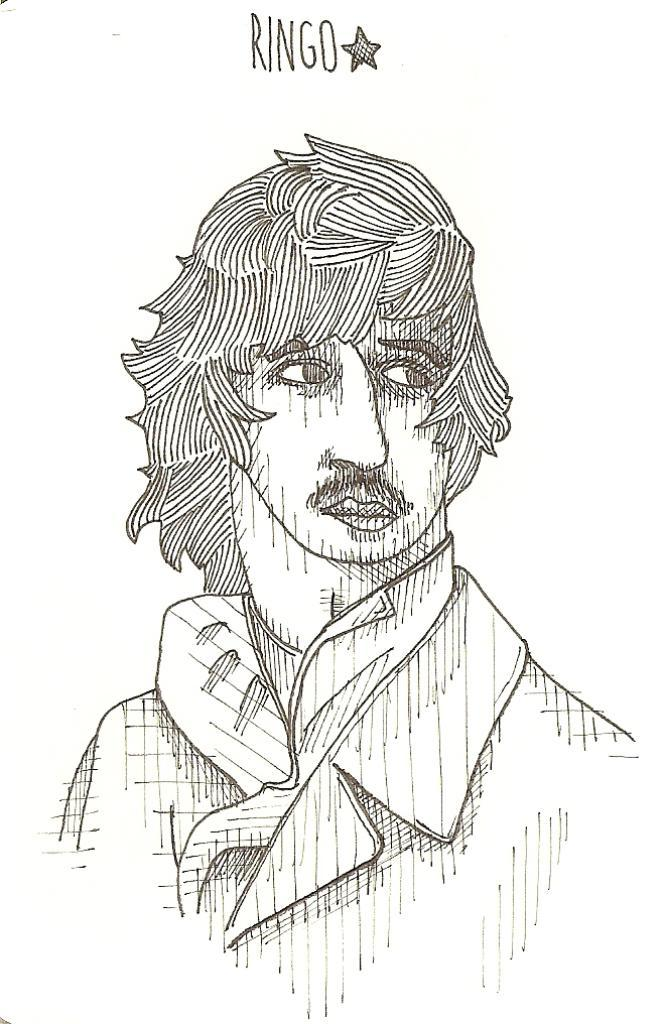What is depicted in the image? There is a sketch drawing of a person in the image. Can you describe any additional elements in the image? There is text on the top of the sketch drawing. What type of fruit is being held by the person in the sketch drawing? There is no fruit visible in the sketch drawing; it only depicts a person. Is there any dust present on the sketch drawing in the image? The image does not provide information about the presence of dust on the sketch drawing. 